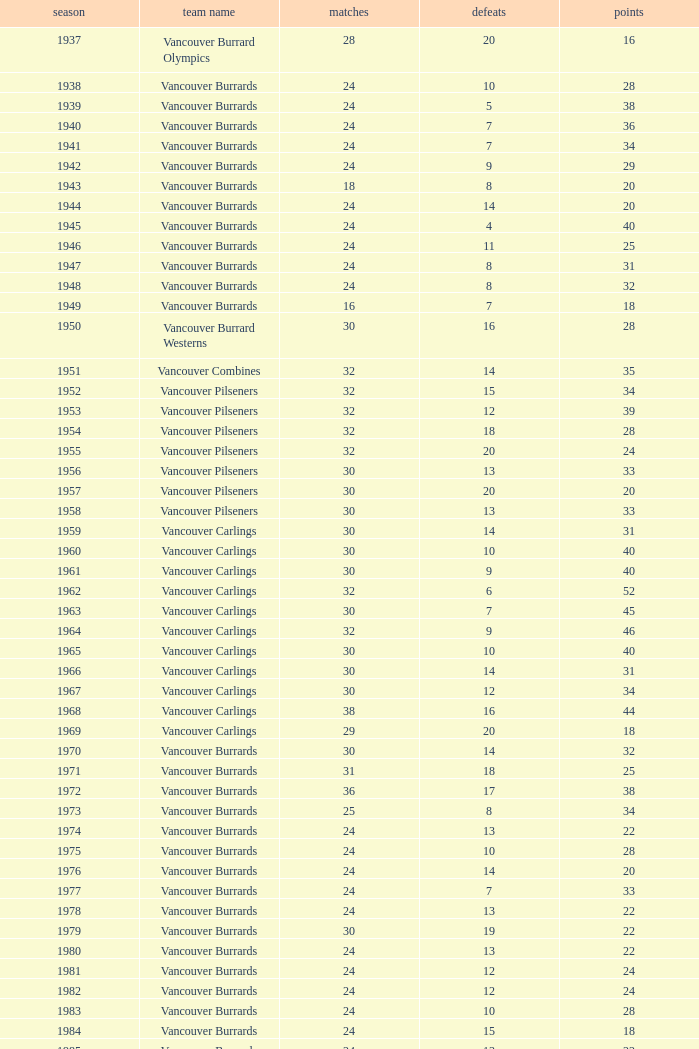What's the total losses for the vancouver burrards in the 1947 season with fewer than 24 games? 0.0. Could you help me parse every detail presented in this table? {'header': ['season', 'team name', 'matches', 'defeats', 'points'], 'rows': [['1937', 'Vancouver Burrard Olympics', '28', '20', '16'], ['1938', 'Vancouver Burrards', '24', '10', '28'], ['1939', 'Vancouver Burrards', '24', '5', '38'], ['1940', 'Vancouver Burrards', '24', '7', '36'], ['1941', 'Vancouver Burrards', '24', '7', '34'], ['1942', 'Vancouver Burrards', '24', '9', '29'], ['1943', 'Vancouver Burrards', '18', '8', '20'], ['1944', 'Vancouver Burrards', '24', '14', '20'], ['1945', 'Vancouver Burrards', '24', '4', '40'], ['1946', 'Vancouver Burrards', '24', '11', '25'], ['1947', 'Vancouver Burrards', '24', '8', '31'], ['1948', 'Vancouver Burrards', '24', '8', '32'], ['1949', 'Vancouver Burrards', '16', '7', '18'], ['1950', 'Vancouver Burrard Westerns', '30', '16', '28'], ['1951', 'Vancouver Combines', '32', '14', '35'], ['1952', 'Vancouver Pilseners', '32', '15', '34'], ['1953', 'Vancouver Pilseners', '32', '12', '39'], ['1954', 'Vancouver Pilseners', '32', '18', '28'], ['1955', 'Vancouver Pilseners', '32', '20', '24'], ['1956', 'Vancouver Pilseners', '30', '13', '33'], ['1957', 'Vancouver Pilseners', '30', '20', '20'], ['1958', 'Vancouver Pilseners', '30', '13', '33'], ['1959', 'Vancouver Carlings', '30', '14', '31'], ['1960', 'Vancouver Carlings', '30', '10', '40'], ['1961', 'Vancouver Carlings', '30', '9', '40'], ['1962', 'Vancouver Carlings', '32', '6', '52'], ['1963', 'Vancouver Carlings', '30', '7', '45'], ['1964', 'Vancouver Carlings', '32', '9', '46'], ['1965', 'Vancouver Carlings', '30', '10', '40'], ['1966', 'Vancouver Carlings', '30', '14', '31'], ['1967', 'Vancouver Carlings', '30', '12', '34'], ['1968', 'Vancouver Carlings', '38', '16', '44'], ['1969', 'Vancouver Carlings', '29', '20', '18'], ['1970', 'Vancouver Burrards', '30', '14', '32'], ['1971', 'Vancouver Burrards', '31', '18', '25'], ['1972', 'Vancouver Burrards', '36', '17', '38'], ['1973', 'Vancouver Burrards', '25', '8', '34'], ['1974', 'Vancouver Burrards', '24', '13', '22'], ['1975', 'Vancouver Burrards', '24', '10', '28'], ['1976', 'Vancouver Burrards', '24', '14', '20'], ['1977', 'Vancouver Burrards', '24', '7', '33'], ['1978', 'Vancouver Burrards', '24', '13', '22'], ['1979', 'Vancouver Burrards', '30', '19', '22'], ['1980', 'Vancouver Burrards', '24', '13', '22'], ['1981', 'Vancouver Burrards', '24', '12', '24'], ['1982', 'Vancouver Burrards', '24', '12', '24'], ['1983', 'Vancouver Burrards', '24', '10', '28'], ['1984', 'Vancouver Burrards', '24', '15', '18'], ['1985', 'Vancouver Burrards', '24', '13', '22'], ['1986', 'Vancouver Burrards', '24', '11', '26'], ['1987', 'Vancouver Burrards', '24', '14', '20'], ['1988', 'Vancouver Burrards', '24', '13', '22'], ['1989', 'Vancouver Burrards', '24', '15', '18'], ['1990', 'Vancouver Burrards', '24', '8', '32'], ['1991', 'Vancouver Burrards', '24', '16', '16'], ['1992', 'Vancouver Burrards', '24', '15', '18'], ['1993', 'Vancouver Burrards', '24', '20', '8'], ['1994', 'Surrey Burrards', '20', '12', '16'], ['1995', 'Surrey Burrards', '25', '19', '11'], ['1996', 'Maple Ridge Burrards', '20', '8', '23'], ['1997', 'Maple Ridge Burrards', '20', '8', '23'], ['1998', 'Maple Ridge Burrards', '25', '8', '32'], ['1999', 'Maple Ridge Burrards', '25', '15', '20'], ['2000', 'Maple Ridge Burrards', '25', '16', '18'], ['2001', 'Maple Ridge Burrards', '20', '16', '8'], ['2002', 'Maple Ridge Burrards', '20', '15', '8'], ['2003', 'Maple Ridge Burrards', '20', '15', '10'], ['2004', 'Maple Ridge Burrards', '20', '12', '16'], ['2005', 'Maple Ridge Burrards', '18', '8', '19'], ['2006', 'Maple Ridge Burrards', '18', '11', '14'], ['2007', 'Maple Ridge Burrards', '18', '11', '14'], ['2008', 'Maple Ridge Burrards', '18', '13', '10'], ['2009', 'Maple Ridge Burrards', '18', '11', '14'], ['2010', 'Maple Ridge Burrards', '18', '9', '18'], ['Total', '74 seasons', '1,879', '913', '1,916']]} 